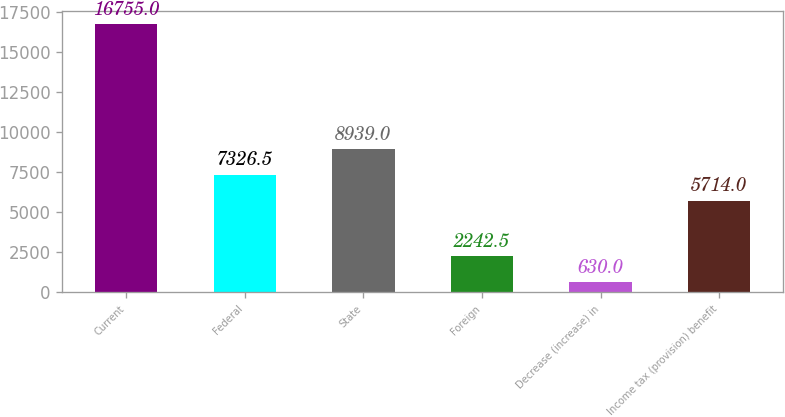Convert chart. <chart><loc_0><loc_0><loc_500><loc_500><bar_chart><fcel>Current<fcel>Federal<fcel>State<fcel>Foreign<fcel>Decrease (increase) in<fcel>Income tax (provision) benefit<nl><fcel>16755<fcel>7326.5<fcel>8939<fcel>2242.5<fcel>630<fcel>5714<nl></chart> 